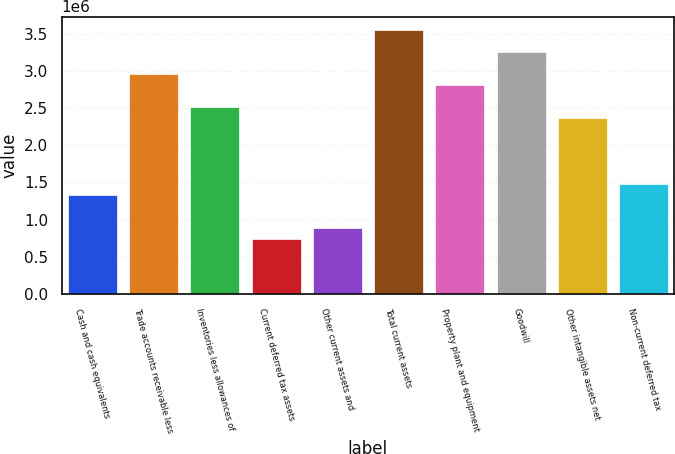Convert chart. <chart><loc_0><loc_0><loc_500><loc_500><bar_chart><fcel>Cash and cash equivalents<fcel>Trade accounts receivable less<fcel>Inventories less allowances of<fcel>Current deferred tax assets<fcel>Other current assets and<fcel>Total current assets<fcel>Property plant and equipment<fcel>Goodwill<fcel>Other intangible assets net<fcel>Non-current deferred tax<nl><fcel>1.33211e+06<fcel>2.9597e+06<fcel>2.51581e+06<fcel>740260<fcel>888222<fcel>3.55155e+06<fcel>2.81173e+06<fcel>3.25562e+06<fcel>2.36785e+06<fcel>1.48007e+06<nl></chart> 